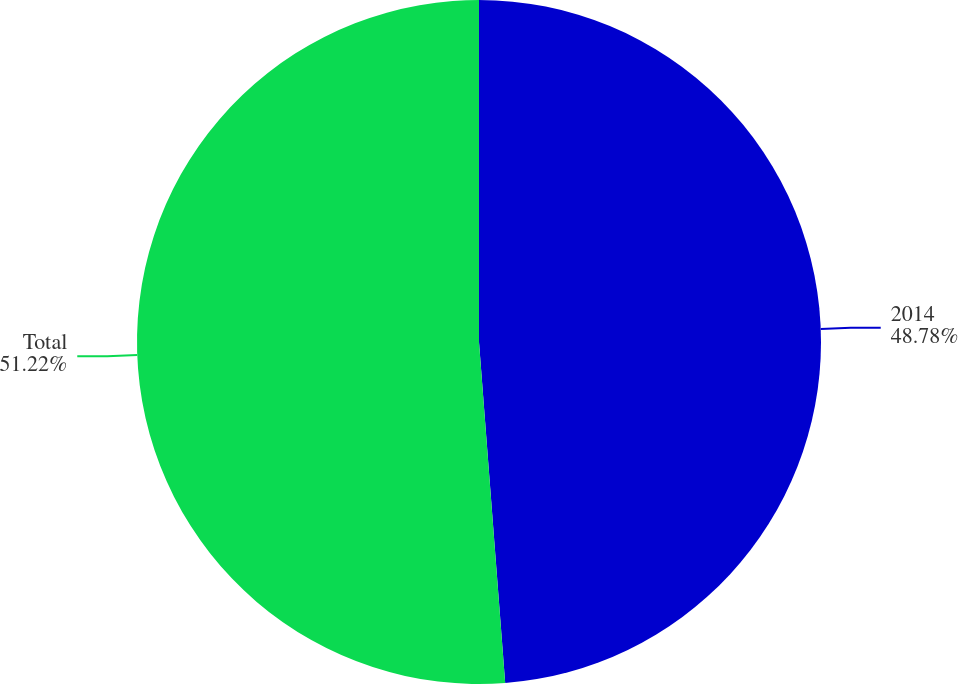<chart> <loc_0><loc_0><loc_500><loc_500><pie_chart><fcel>2014<fcel>Total<nl><fcel>48.78%<fcel>51.22%<nl></chart> 